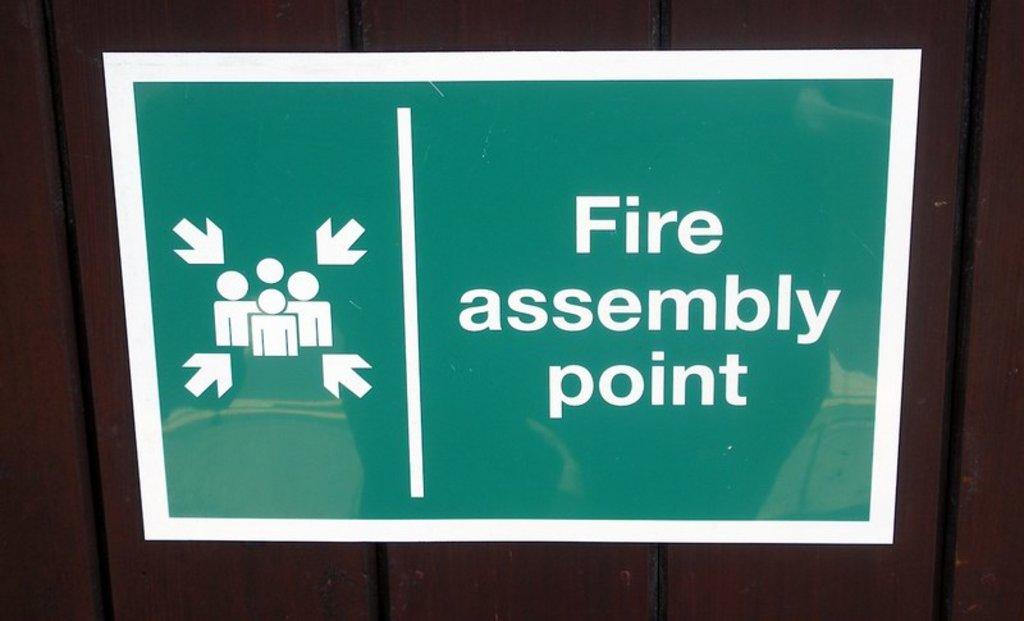Provide a one-sentence caption for the provided image. A sign that says fire assembly point is being shown. 